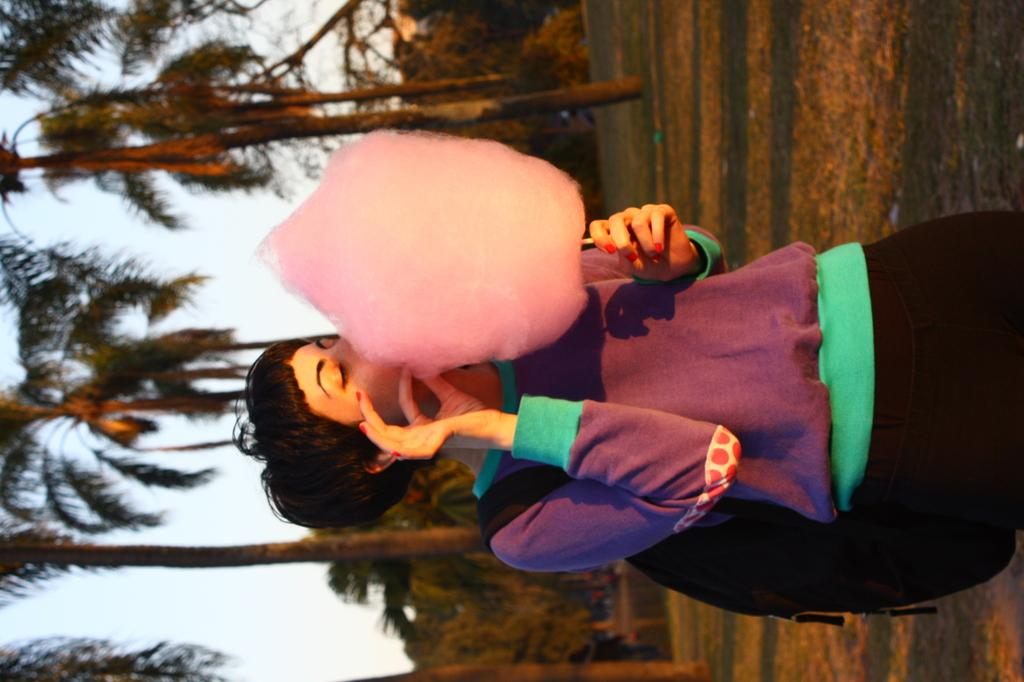Who is present in the image? There is a lady in the image. What is the lady wearing? The lady is wearing a bag. What is the lady holding in the image? The lady is holding a cotton candy. What can be seen in the background of the image? There are trees and the sky visible in the background of the image. What month is it in the image? The month cannot be determined from the image, as there is no information about the time of year or specific date. 